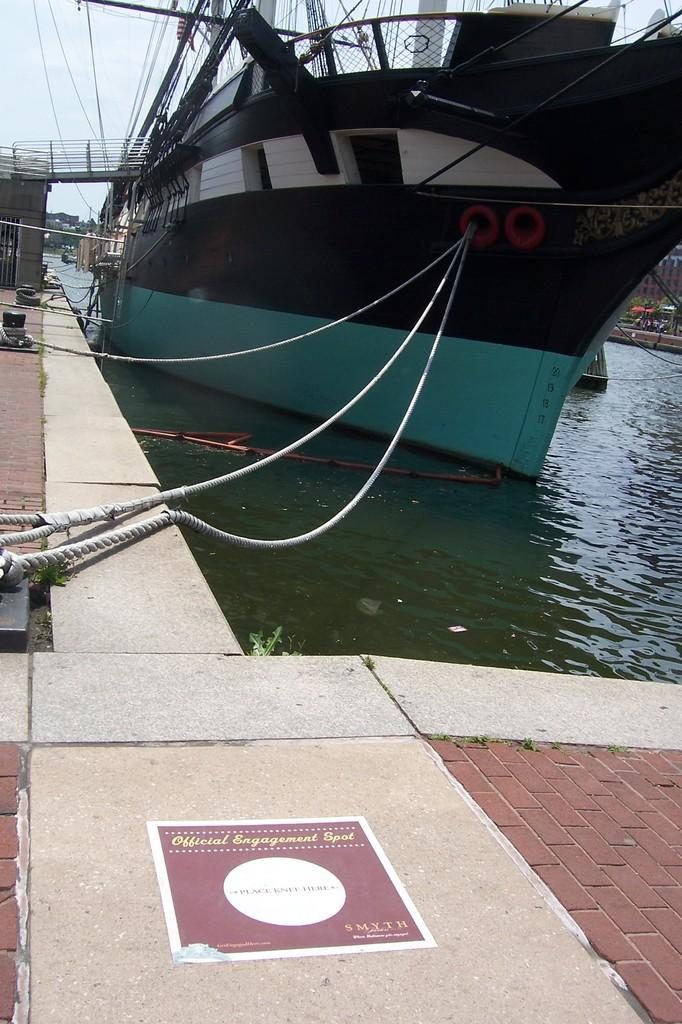What is in the water in the image? There is a boat in the water in the image. What colors can be seen on the boat? The boat is in black and blue color. What is visible at the top of the picture? There are wires and the sky visible at the top of the picture. What can be seen in the background of the image? There are trees in the background of the image. Where is the hammer being used in the image? There is no hammer present in the image. What type of lift is visible in the image? There is no lift present in the image. 